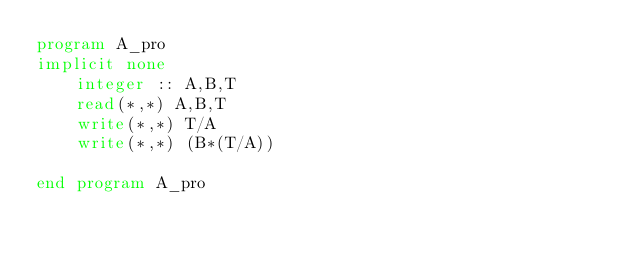Convert code to text. <code><loc_0><loc_0><loc_500><loc_500><_FORTRAN_>program A_pro
implicit none
    integer :: A,B,T
    read(*,*) A,B,T
    write(*,*) T/A
    write(*,*) (B*(T/A))

end program A_pro</code> 